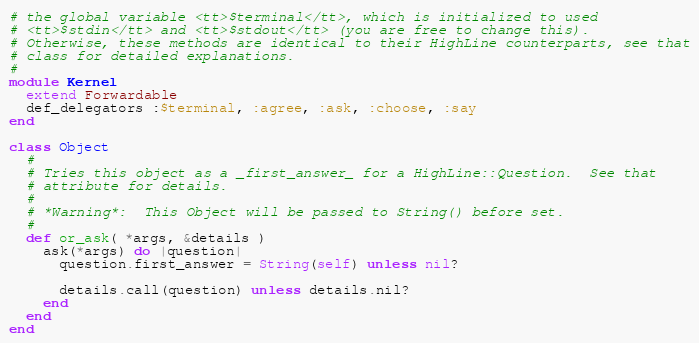Convert code to text. <code><loc_0><loc_0><loc_500><loc_500><_Ruby_># the global variable <tt>$terminal</tt>, which is initialized to used
# <tt>$stdin</tt> and <tt>$stdout</tt> (you are free to change this).
# Otherwise, these methods are identical to their HighLine counterparts, see that
# class for detailed explanations.
#
module Kernel
  extend Forwardable
  def_delegators :$terminal, :agree, :ask, :choose, :say
end

class Object
  # 
  # Tries this object as a _first_answer_ for a HighLine::Question.  See that
  # attribute for details.
  # 
  # *Warning*:  This Object will be passed to String() before set.
  # 
  def or_ask( *args, &details )
    ask(*args) do |question|
      question.first_answer = String(self) unless nil?
      
      details.call(question) unless details.nil?
    end
  end
end
</code> 